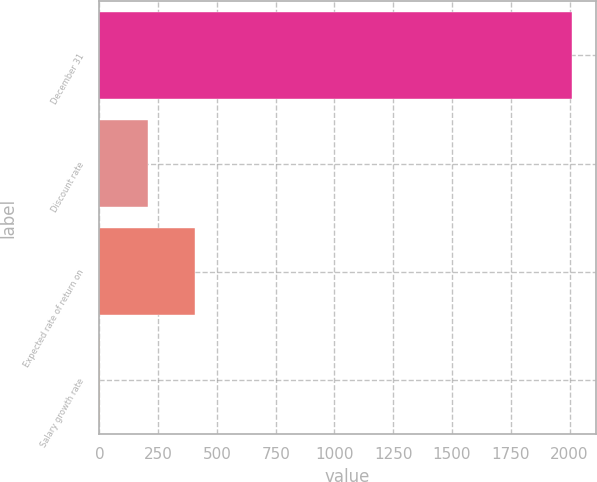Convert chart to OTSL. <chart><loc_0><loc_0><loc_500><loc_500><bar_chart><fcel>December 31<fcel>Discount rate<fcel>Expected rate of return on<fcel>Salary growth rate<nl><fcel>2011<fcel>204.88<fcel>405.56<fcel>4.2<nl></chart> 